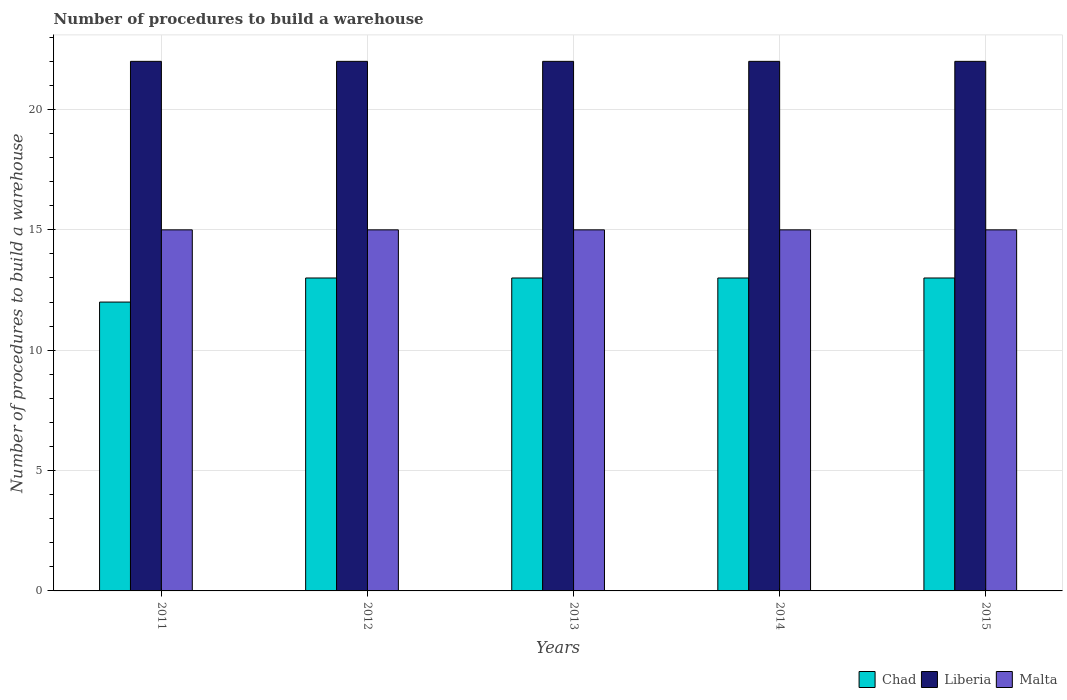Are the number of bars per tick equal to the number of legend labels?
Offer a very short reply. Yes. How many bars are there on the 1st tick from the right?
Offer a very short reply. 3. In how many cases, is the number of bars for a given year not equal to the number of legend labels?
Your answer should be compact. 0. What is the number of procedures to build a warehouse in in Chad in 2014?
Offer a terse response. 13. Across all years, what is the maximum number of procedures to build a warehouse in in Liberia?
Your response must be concise. 22. Across all years, what is the minimum number of procedures to build a warehouse in in Chad?
Offer a very short reply. 12. What is the total number of procedures to build a warehouse in in Chad in the graph?
Your answer should be compact. 64. In the year 2013, what is the difference between the number of procedures to build a warehouse in in Chad and number of procedures to build a warehouse in in Malta?
Keep it short and to the point. -2. In how many years, is the number of procedures to build a warehouse in in Malta greater than 4?
Ensure brevity in your answer.  5. Is the number of procedures to build a warehouse in in Chad in 2011 less than that in 2015?
Give a very brief answer. Yes. Is the difference between the number of procedures to build a warehouse in in Chad in 2013 and 2014 greater than the difference between the number of procedures to build a warehouse in in Malta in 2013 and 2014?
Your response must be concise. No. What is the difference between the highest and the lowest number of procedures to build a warehouse in in Malta?
Make the answer very short. 0. What does the 2nd bar from the left in 2011 represents?
Make the answer very short. Liberia. What does the 3rd bar from the right in 2011 represents?
Make the answer very short. Chad. Is it the case that in every year, the sum of the number of procedures to build a warehouse in in Chad and number of procedures to build a warehouse in in Liberia is greater than the number of procedures to build a warehouse in in Malta?
Your answer should be very brief. Yes. How many bars are there?
Make the answer very short. 15. Are all the bars in the graph horizontal?
Provide a succinct answer. No. How many years are there in the graph?
Ensure brevity in your answer.  5. What is the difference between two consecutive major ticks on the Y-axis?
Provide a succinct answer. 5. Are the values on the major ticks of Y-axis written in scientific E-notation?
Give a very brief answer. No. Does the graph contain grids?
Give a very brief answer. Yes. How are the legend labels stacked?
Keep it short and to the point. Horizontal. What is the title of the graph?
Provide a short and direct response. Number of procedures to build a warehouse. Does "Swaziland" appear as one of the legend labels in the graph?
Keep it short and to the point. No. What is the label or title of the X-axis?
Your answer should be compact. Years. What is the label or title of the Y-axis?
Provide a short and direct response. Number of procedures to build a warehouse. What is the Number of procedures to build a warehouse of Chad in 2011?
Your response must be concise. 12. What is the Number of procedures to build a warehouse in Liberia in 2012?
Offer a very short reply. 22. What is the Number of procedures to build a warehouse in Malta in 2012?
Provide a short and direct response. 15. What is the Number of procedures to build a warehouse in Liberia in 2013?
Ensure brevity in your answer.  22. What is the Number of procedures to build a warehouse of Malta in 2014?
Provide a succinct answer. 15. What is the Number of procedures to build a warehouse of Chad in 2015?
Offer a very short reply. 13. What is the Number of procedures to build a warehouse in Liberia in 2015?
Keep it short and to the point. 22. What is the Number of procedures to build a warehouse in Malta in 2015?
Ensure brevity in your answer.  15. Across all years, what is the maximum Number of procedures to build a warehouse of Liberia?
Your response must be concise. 22. Across all years, what is the maximum Number of procedures to build a warehouse in Malta?
Provide a succinct answer. 15. Across all years, what is the minimum Number of procedures to build a warehouse of Chad?
Keep it short and to the point. 12. Across all years, what is the minimum Number of procedures to build a warehouse in Malta?
Your response must be concise. 15. What is the total Number of procedures to build a warehouse of Liberia in the graph?
Provide a short and direct response. 110. What is the difference between the Number of procedures to build a warehouse in Chad in 2011 and that in 2012?
Your answer should be very brief. -1. What is the difference between the Number of procedures to build a warehouse in Liberia in 2011 and that in 2012?
Ensure brevity in your answer.  0. What is the difference between the Number of procedures to build a warehouse in Liberia in 2011 and that in 2013?
Provide a succinct answer. 0. What is the difference between the Number of procedures to build a warehouse of Malta in 2011 and that in 2013?
Offer a very short reply. 0. What is the difference between the Number of procedures to build a warehouse of Chad in 2011 and that in 2014?
Keep it short and to the point. -1. What is the difference between the Number of procedures to build a warehouse in Malta in 2011 and that in 2014?
Provide a short and direct response. 0. What is the difference between the Number of procedures to build a warehouse in Chad in 2011 and that in 2015?
Offer a terse response. -1. What is the difference between the Number of procedures to build a warehouse of Liberia in 2011 and that in 2015?
Provide a succinct answer. 0. What is the difference between the Number of procedures to build a warehouse in Chad in 2012 and that in 2013?
Give a very brief answer. 0. What is the difference between the Number of procedures to build a warehouse of Liberia in 2012 and that in 2013?
Your answer should be very brief. 0. What is the difference between the Number of procedures to build a warehouse in Malta in 2012 and that in 2013?
Your answer should be compact. 0. What is the difference between the Number of procedures to build a warehouse of Chad in 2012 and that in 2014?
Your answer should be very brief. 0. What is the difference between the Number of procedures to build a warehouse in Malta in 2012 and that in 2014?
Offer a terse response. 0. What is the difference between the Number of procedures to build a warehouse of Malta in 2013 and that in 2014?
Provide a short and direct response. 0. What is the difference between the Number of procedures to build a warehouse in Liberia in 2013 and that in 2015?
Provide a succinct answer. 0. What is the difference between the Number of procedures to build a warehouse of Chad in 2014 and that in 2015?
Your answer should be compact. 0. What is the difference between the Number of procedures to build a warehouse of Liberia in 2014 and that in 2015?
Your response must be concise. 0. What is the difference between the Number of procedures to build a warehouse in Malta in 2014 and that in 2015?
Give a very brief answer. 0. What is the difference between the Number of procedures to build a warehouse in Chad in 2011 and the Number of procedures to build a warehouse in Malta in 2012?
Your answer should be compact. -3. What is the difference between the Number of procedures to build a warehouse in Liberia in 2011 and the Number of procedures to build a warehouse in Malta in 2012?
Your answer should be very brief. 7. What is the difference between the Number of procedures to build a warehouse of Chad in 2011 and the Number of procedures to build a warehouse of Malta in 2013?
Your answer should be compact. -3. What is the difference between the Number of procedures to build a warehouse of Chad in 2012 and the Number of procedures to build a warehouse of Malta in 2014?
Your answer should be compact. -2. What is the difference between the Number of procedures to build a warehouse in Chad in 2012 and the Number of procedures to build a warehouse in Liberia in 2015?
Give a very brief answer. -9. What is the difference between the Number of procedures to build a warehouse of Liberia in 2012 and the Number of procedures to build a warehouse of Malta in 2015?
Keep it short and to the point. 7. What is the difference between the Number of procedures to build a warehouse of Chad in 2013 and the Number of procedures to build a warehouse of Liberia in 2014?
Provide a succinct answer. -9. What is the difference between the Number of procedures to build a warehouse in Chad in 2013 and the Number of procedures to build a warehouse in Malta in 2014?
Ensure brevity in your answer.  -2. What is the difference between the Number of procedures to build a warehouse in Liberia in 2013 and the Number of procedures to build a warehouse in Malta in 2014?
Offer a terse response. 7. What is the difference between the Number of procedures to build a warehouse of Liberia in 2013 and the Number of procedures to build a warehouse of Malta in 2015?
Your answer should be compact. 7. In the year 2011, what is the difference between the Number of procedures to build a warehouse of Chad and Number of procedures to build a warehouse of Liberia?
Your answer should be compact. -10. In the year 2012, what is the difference between the Number of procedures to build a warehouse of Chad and Number of procedures to build a warehouse of Liberia?
Provide a succinct answer. -9. In the year 2012, what is the difference between the Number of procedures to build a warehouse of Liberia and Number of procedures to build a warehouse of Malta?
Offer a terse response. 7. In the year 2013, what is the difference between the Number of procedures to build a warehouse in Chad and Number of procedures to build a warehouse in Malta?
Offer a terse response. -2. In the year 2013, what is the difference between the Number of procedures to build a warehouse in Liberia and Number of procedures to build a warehouse in Malta?
Ensure brevity in your answer.  7. In the year 2014, what is the difference between the Number of procedures to build a warehouse of Chad and Number of procedures to build a warehouse of Malta?
Your answer should be compact. -2. In the year 2014, what is the difference between the Number of procedures to build a warehouse of Liberia and Number of procedures to build a warehouse of Malta?
Make the answer very short. 7. In the year 2015, what is the difference between the Number of procedures to build a warehouse of Chad and Number of procedures to build a warehouse of Liberia?
Provide a succinct answer. -9. What is the ratio of the Number of procedures to build a warehouse of Chad in 2011 to that in 2012?
Offer a very short reply. 0.92. What is the ratio of the Number of procedures to build a warehouse in Liberia in 2011 to that in 2012?
Make the answer very short. 1. What is the ratio of the Number of procedures to build a warehouse of Liberia in 2011 to that in 2013?
Your response must be concise. 1. What is the ratio of the Number of procedures to build a warehouse of Liberia in 2011 to that in 2014?
Give a very brief answer. 1. What is the ratio of the Number of procedures to build a warehouse of Malta in 2011 to that in 2014?
Offer a terse response. 1. What is the ratio of the Number of procedures to build a warehouse of Liberia in 2012 to that in 2013?
Offer a terse response. 1. What is the ratio of the Number of procedures to build a warehouse in Chad in 2012 to that in 2014?
Keep it short and to the point. 1. What is the ratio of the Number of procedures to build a warehouse in Liberia in 2012 to that in 2014?
Your answer should be very brief. 1. What is the ratio of the Number of procedures to build a warehouse of Liberia in 2012 to that in 2015?
Ensure brevity in your answer.  1. What is the ratio of the Number of procedures to build a warehouse of Chad in 2013 to that in 2014?
Make the answer very short. 1. What is the ratio of the Number of procedures to build a warehouse of Liberia in 2013 to that in 2014?
Give a very brief answer. 1. What is the ratio of the Number of procedures to build a warehouse of Malta in 2013 to that in 2014?
Provide a succinct answer. 1. What is the ratio of the Number of procedures to build a warehouse of Chad in 2013 to that in 2015?
Offer a very short reply. 1. What is the ratio of the Number of procedures to build a warehouse in Malta in 2013 to that in 2015?
Provide a short and direct response. 1. What is the ratio of the Number of procedures to build a warehouse in Chad in 2014 to that in 2015?
Give a very brief answer. 1. What is the ratio of the Number of procedures to build a warehouse in Liberia in 2014 to that in 2015?
Your answer should be compact. 1. What is the difference between the highest and the second highest Number of procedures to build a warehouse of Chad?
Provide a succinct answer. 0. What is the difference between the highest and the second highest Number of procedures to build a warehouse in Liberia?
Give a very brief answer. 0. What is the difference between the highest and the lowest Number of procedures to build a warehouse in Malta?
Ensure brevity in your answer.  0. 